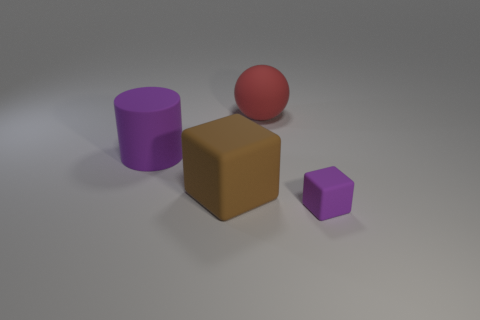What is the size of the thing that is the same color as the tiny cube?
Provide a short and direct response. Large. Do the purple object that is behind the small matte thing and the object that is in front of the brown block have the same shape?
Your response must be concise. No. Are there any blue metal spheres?
Your response must be concise. No. The other object that is the same shape as the brown matte thing is what color?
Your response must be concise. Purple. What is the color of the matte block that is the same size as the purple cylinder?
Keep it short and to the point. Brown. Is the tiny block made of the same material as the big red thing?
Your answer should be compact. Yes. How many other matte cylinders are the same color as the large cylinder?
Your response must be concise. 0. Is the color of the big matte cylinder the same as the big rubber ball?
Your response must be concise. No. What material is the cube that is on the right side of the red thing?
Provide a short and direct response. Rubber. How many large things are purple matte objects or rubber balls?
Ensure brevity in your answer.  2. 